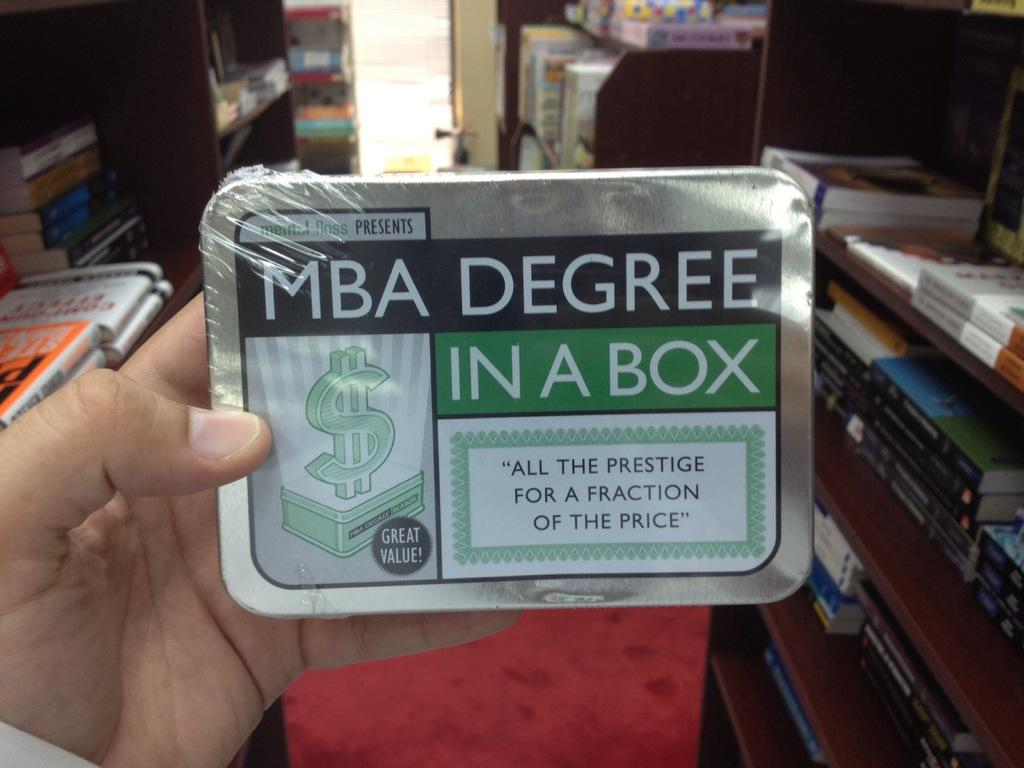<image>
Summarize the visual content of the image. a box with a label on it that says 'mba degree in a box' 